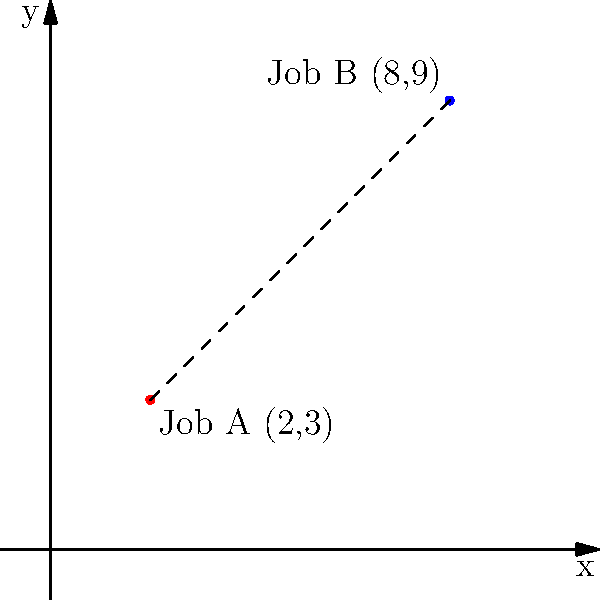You're considering two job opportunities in different parts of the city. Job A is located at coordinates (2,3), and Job B is at (8,9) on the city grid. Each unit on the grid represents 1 mile. What is the straight-line distance between these two job locations? Round your answer to the nearest tenth of a mile. To find the straight-line distance between two points on a coordinate plane, we can use the distance formula, which is derived from the Pythagorean theorem:

$$d = \sqrt{(x_2 - x_1)^2 + (y_2 - y_1)^2}$$

Where $(x_1, y_1)$ is the first point and $(x_2, y_2)$ is the second point.

Let's plug in our values:
Job A: $(x_1, y_1) = (2, 3)$
Job B: $(x_2, y_2) = (8, 9)$

Now, let's calculate:

1) $d = \sqrt{(8 - 2)^2 + (9 - 3)^2}$

2) $d = \sqrt{6^2 + 6^2}$

3) $d = \sqrt{36 + 36}$

4) $d = \sqrt{72}$

5) $d \approx 8.4853$

Rounding to the nearest tenth:

6) $d \approx 8.5$ miles

Therefore, the straight-line distance between the two job locations is approximately 8.5 miles.
Answer: 8.5 miles 